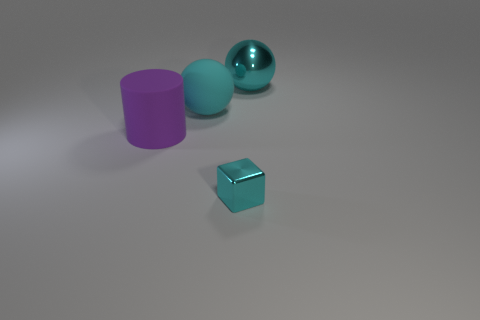How many objects are tiny purple shiny things or balls?
Make the answer very short. 2. There is a cyan metal object that is in front of the cyan shiny ball; what size is it?
Your answer should be compact. Small. What number of other things are made of the same material as the large purple cylinder?
Your answer should be very brief. 1. There is a cyan metallic object that is in front of the cylinder; are there any big cyan matte things that are to the left of it?
Your response must be concise. Yes. Is there any other thing that is the same shape as the small metal thing?
Your answer should be very brief. No. What color is the other thing that is the same shape as the large cyan rubber thing?
Your response must be concise. Cyan. What size is the cyan metallic block?
Give a very brief answer. Small. Are there fewer things to the left of the large purple rubber object than cyan cylinders?
Your response must be concise. No. Do the tiny cyan block and the sphere that is to the right of the cyan shiny cube have the same material?
Keep it short and to the point. Yes. Are there any purple cylinders that are in front of the shiny object that is behind the thing to the left of the big cyan rubber thing?
Keep it short and to the point. Yes. 